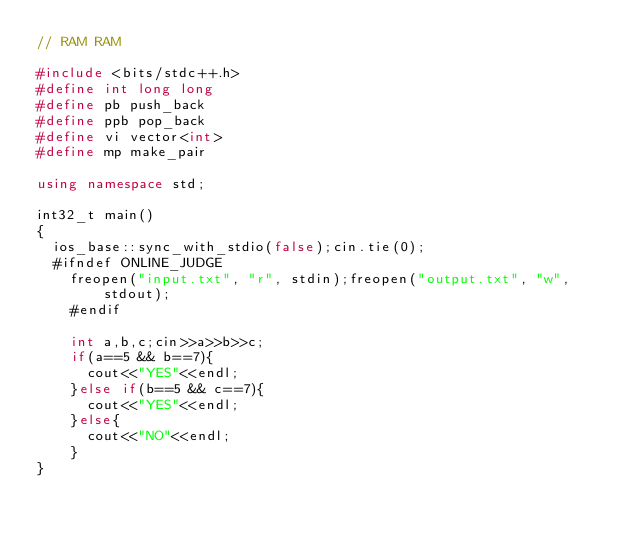<code> <loc_0><loc_0><loc_500><loc_500><_C++_>// RAM RAM

#include <bits/stdc++.h>
#define int long long
#define pb push_back
#define ppb pop_back
#define vi vector<int>
#define mp make_pair

using namespace std;

int32_t main()
{
	ios_base::sync_with_stdio(false);cin.tie(0);
	#ifndef ONLINE_JUDGE
    freopen("input.txt", "r", stdin);freopen("output.txt", "w", stdout);
    #endif
	
    int a,b,c;cin>>a>>b>>c;
    if(a==5 && b==7){
    	cout<<"YES"<<endl;
    }else if(b==5 && c==7){
    	cout<<"YES"<<endl;
    }else{
    	cout<<"NO"<<endl;
    }
}</code> 